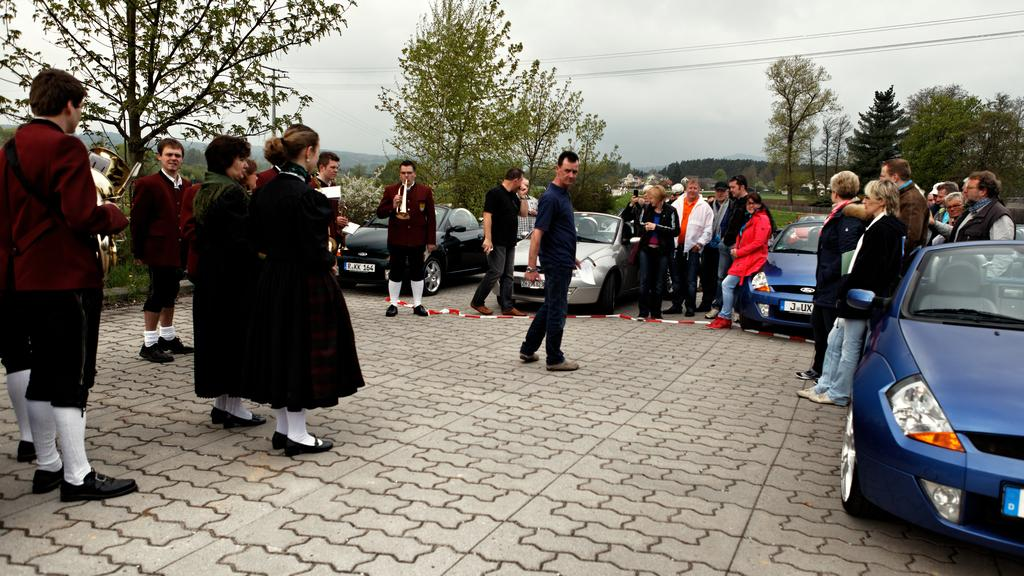How many people are present in the image? There are many people in the image. What else can be seen besides people in the image? There are cars, trees, grass, an electric pole, and a sky visible in the image. What type of vegetation is present in the image? There are trees and grass in the image. What is the background of the image? The background of the image includes an electric pole, trees, grass, and a sky. What type of food is being prepared by the giants in the image? There are no giants present in the image, and therefore no food preparation can be observed. What type of jam is being served on the table in the image? There is no jam present in the image; it only features people, cars, trees, grass, an electric pole, and a sky. 